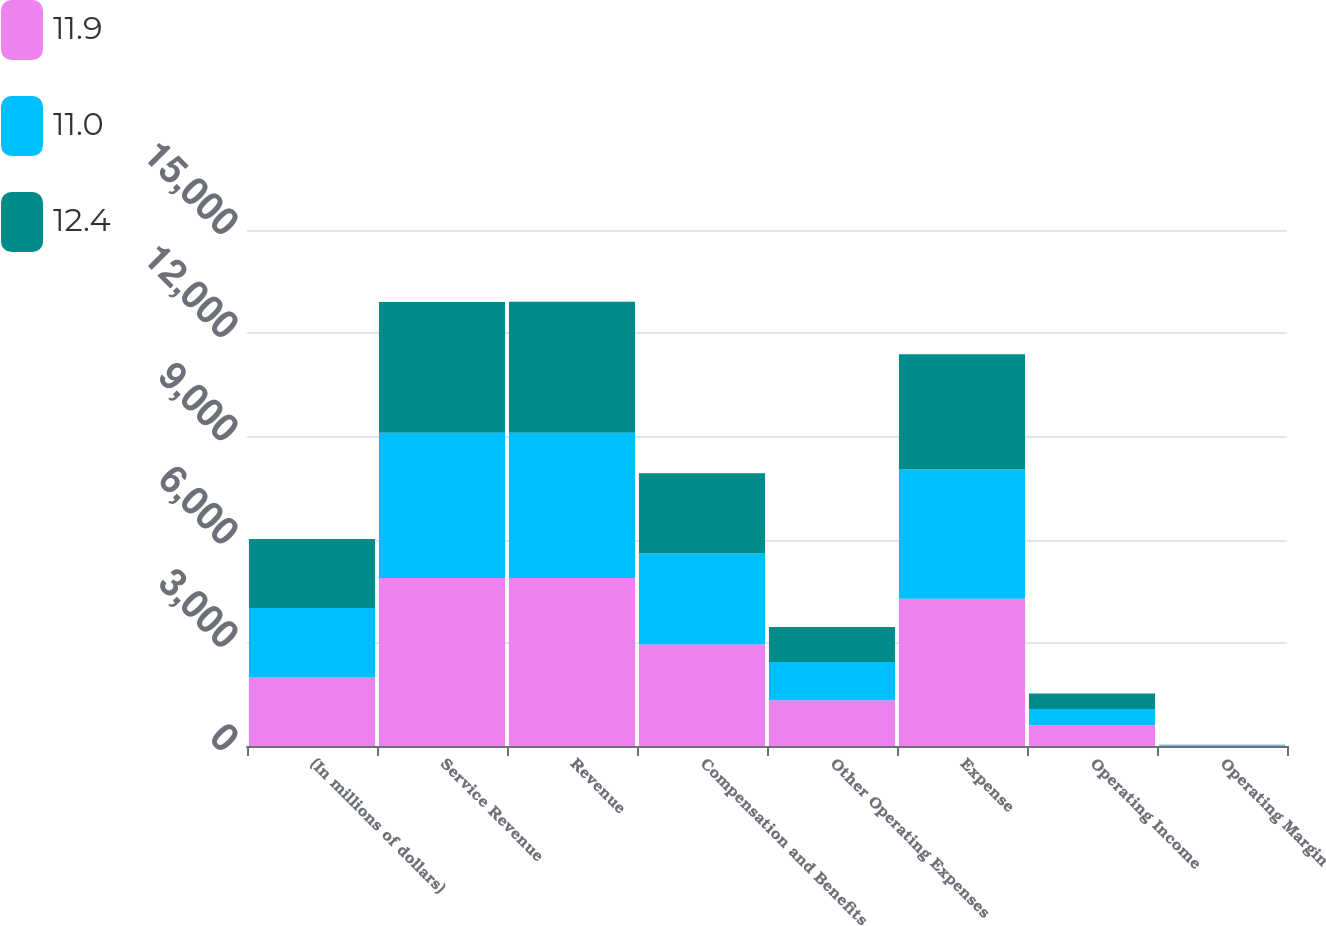Convert chart to OTSL. <chart><loc_0><loc_0><loc_500><loc_500><stacked_bar_chart><ecel><fcel>(In millions of dollars)<fcel>Service Revenue<fcel>Revenue<fcel>Compensation and Benefits<fcel>Other Operating Expenses<fcel>Expense<fcel>Operating Income<fcel>Operating Margin<nl><fcel>11.9<fcel>2007<fcel>4884<fcel>4884<fcel>2951<fcel>1327<fcel>4278<fcel>606<fcel>12.4<nl><fcel>11<fcel>2006<fcel>4224<fcel>4225<fcel>2647<fcel>1112<fcel>3759<fcel>466<fcel>11<nl><fcel>12.4<fcel>2005<fcel>3802<fcel>3802<fcel>2330<fcel>1021<fcel>3351<fcel>451<fcel>11.9<nl></chart> 